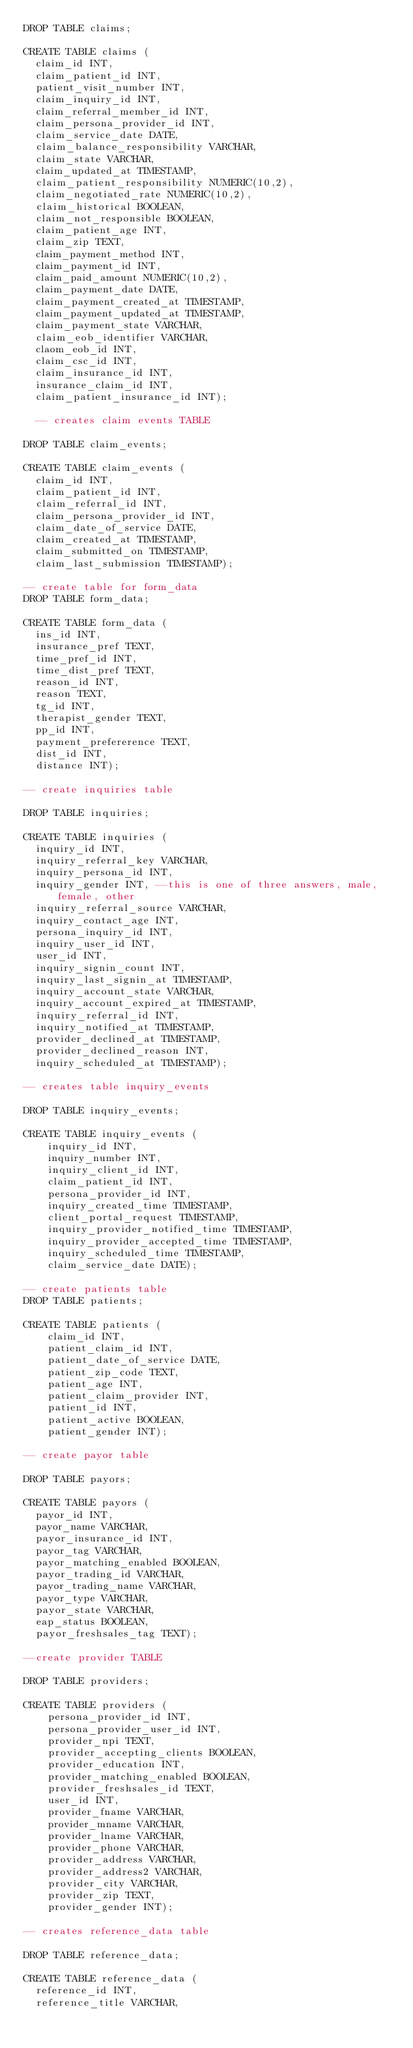Convert code to text. <code><loc_0><loc_0><loc_500><loc_500><_SQL_>DROP TABLE claims;

CREATE TABLE claims (
  claim_id INT,
  claim_patient_id INT,
  patient_visit_number INT,
  claim_inquiry_id INT,
  claim_referral_member_id INT,
  claim_persona_provider_id INT,
  claim_service_date DATE,
  claim_balance_responsibility VARCHAR,
  claim_state VARCHAR,
  claim_updated_at TIMESTAMP,
  claim_patient_responsibility NUMERIC(10,2),
  claim_negotiated_rate NUMERIC(10,2),
  claim_historical BOOLEAN,
  claim_not_responsible BOOLEAN,
  claim_patient_age INT,
  claim_zip TEXT,
  claim_payment_method INT,
  claim_payment_id INT,
  claim_paid_amount NUMERIC(10,2),
  claim_payment_date DATE,
  claim_payment_created_at TIMESTAMP,
  claim_payment_updated_at TIMESTAMP,
  claim_payment_state VARCHAR,
  claim_eob_identifier VARCHAR,
  claom_eob_id INT,
  claim_csc_id INT,
  claim_insurance_id INT,
  insurance_claim_id INT,
  claim_patient_insurance_id INT);

  -- creates claim events TABLE

DROP TABLE claim_events;

CREATE TABLE claim_events (
  claim_id INT,
  claim_patient_id INT,
  claim_referral_id INT,
  claim_persona_provider_id INT,
  claim_date_of_service DATE,
  claim_created_at TIMESTAMP,
  claim_submitted_on TIMESTAMP,
  claim_last_submission TIMESTAMP);

-- create table for form_data
DROP TABLE form_data;

CREATE TABLE form_data (
  ins_id INT,
  insurance_pref TEXT,
  time_pref_id INT,
  time_dist_pref TEXT,
  reason_id INT,
  reason TEXT,
  tg_id INT,
  therapist_gender TEXT,
  pp_id INT,
  payment_prefererence TEXT,
  dist_id INT,
  distance INT);

-- create inquiries table

DROP TABLE inquiries;

CREATE TABLE inquiries (
  inquiry_id INT,
  inquiry_referral_key VARCHAR,
  inquiry_persona_id INT,
  inquiry_gender INT, --this is one of three answers, male, female, other
  inquiry_referral_source VARCHAR,
  inquiry_contact_age INT,
  persona_inquiry_id INT,
  inquiry_user_id INT,
  user_id INT,
  inquiry_signin_count INT,
  inquiry_last_signin_at TIMESTAMP,
  inquiry_account_state VARCHAR,
  inquiry_account_expired_at TIMESTAMP,
  inquiry_referral_id INT,
  inquiry_notified_at TIMESTAMP,
  provider_declined_at TIMESTAMP,
  provider_declined_reason INT,
  inquiry_scheduled_at TIMESTAMP);

-- creates table inquiry_events

DROP TABLE inquiry_events;

CREATE TABLE inquiry_events (
    inquiry_id INT,
    inquiry_number INT,
    inquiry_client_id INT,
    claim_patient_id INT,
    persona_provider_id INT,
    inquiry_created_time TIMESTAMP,
    client_portal_request TIMESTAMP,
    inquiry_provider_notified_time TIMESTAMP,
    inquiry_provider_accepted_time TIMESTAMP,
    inquiry_scheduled_time TIMESTAMP,
    claim_service_date DATE);

-- create patients table
DROP TABLE patients;

CREATE TABLE patients (
    claim_id INT,
    patient_claim_id INT,
    patient_date_of_service DATE,
    patient_zip_code TEXT,
    patient_age INT,
    patient_claim_provider INT,
    patient_id INT,
    patient_active BOOLEAN,
    patient_gender INT);

-- create payor table

DROP TABLE payors;

CREATE TABLE payors (
  payor_id INT,
  payor_name VARCHAR,
  payor_insurance_id INT,
  payor_tag VARCHAR,
  payor_matching_enabled BOOLEAN,
  payor_trading_id VARCHAR,
  payor_trading_name VARCHAR,
  payor_type VARCHAR,
  payor_state VARCHAR,
  eap_status BOOLEAN,
  payor_freshsales_tag TEXT);

--create provider TABLE

DROP TABLE providers;

CREATE TABLE providers (
    persona_provider_id INT,
    persona_provider_user_id INT,
    provider_npi TEXT,
    provider_accepting_clients BOOLEAN,
    provider_education INT,
    provider_matching_enabled BOOLEAN,
    provider_freshsales_id TEXT,
    user_id INT,
    provider_fname VARCHAR,
    provider_mname VARCHAR,
    provider_lname VARCHAR,
    provider_phone VARCHAR,
    provider_address VARCHAR,
    provider_address2 VARCHAR,
    provider_city VARCHAR,
    provider_zip TEXT,
    provider_gender INT);

-- creates reference_data table

DROP TABLE reference_data;

CREATE TABLE reference_data (
  reference_id INT,
  reference_title VARCHAR,</code> 